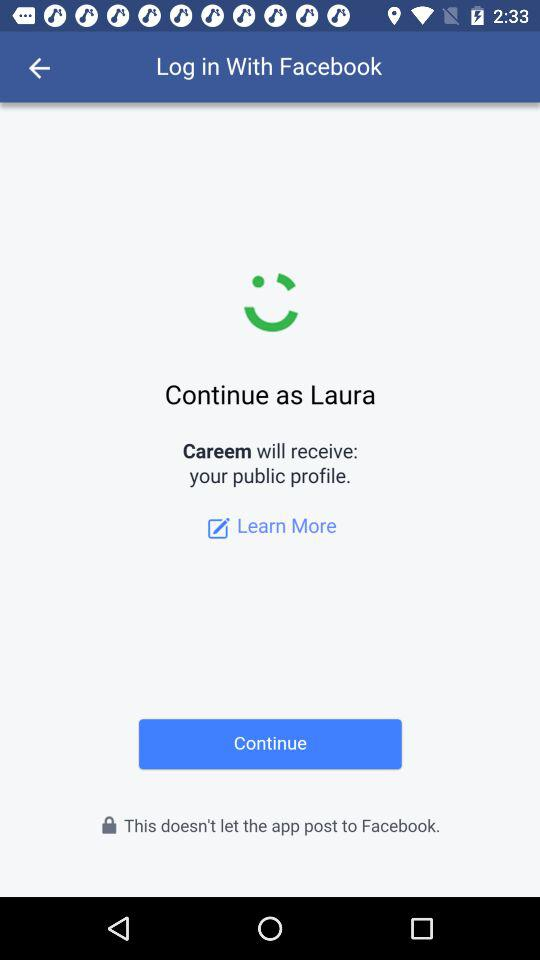What is the application name? The application name is "Careem". 